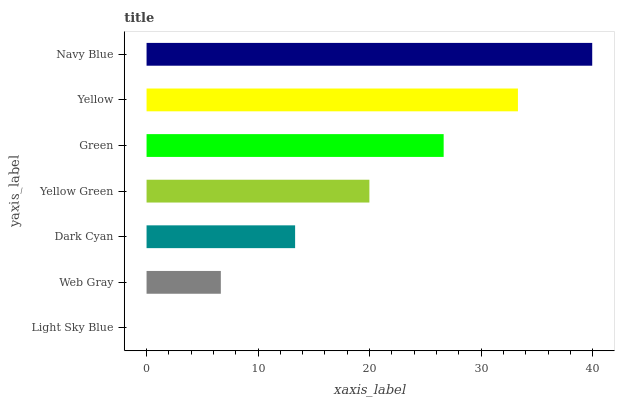Is Light Sky Blue the minimum?
Answer yes or no. Yes. Is Navy Blue the maximum?
Answer yes or no. Yes. Is Web Gray the minimum?
Answer yes or no. No. Is Web Gray the maximum?
Answer yes or no. No. Is Web Gray greater than Light Sky Blue?
Answer yes or no. Yes. Is Light Sky Blue less than Web Gray?
Answer yes or no. Yes. Is Light Sky Blue greater than Web Gray?
Answer yes or no. No. Is Web Gray less than Light Sky Blue?
Answer yes or no. No. Is Yellow Green the high median?
Answer yes or no. Yes. Is Yellow Green the low median?
Answer yes or no. Yes. Is Web Gray the high median?
Answer yes or no. No. Is Dark Cyan the low median?
Answer yes or no. No. 